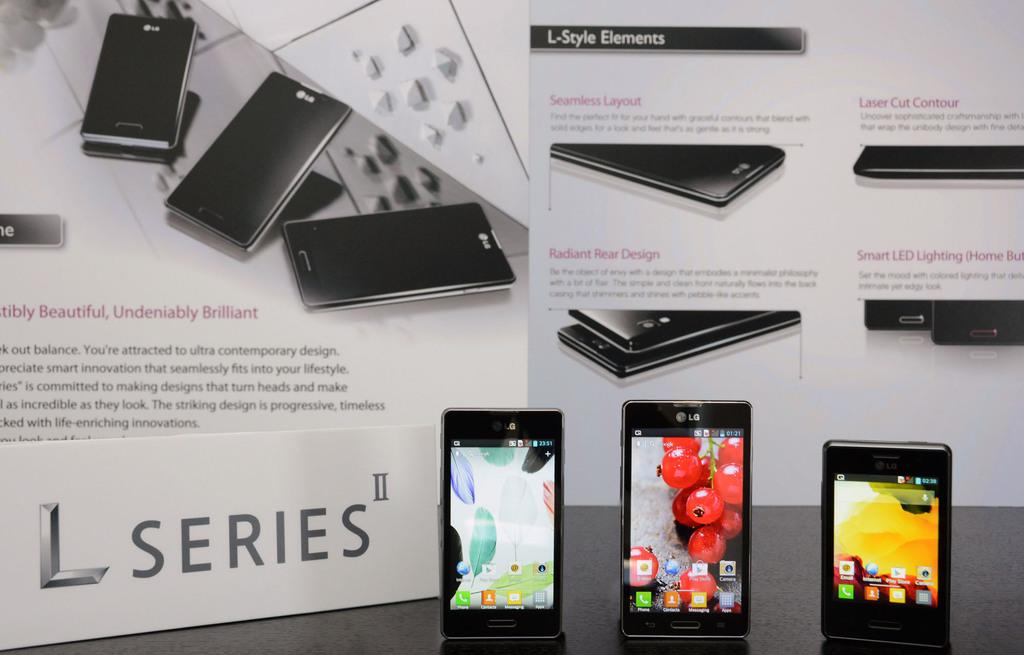What series of phone is this?
Your response must be concise. L series. What style of elements?
Your answer should be very brief. L-style. 